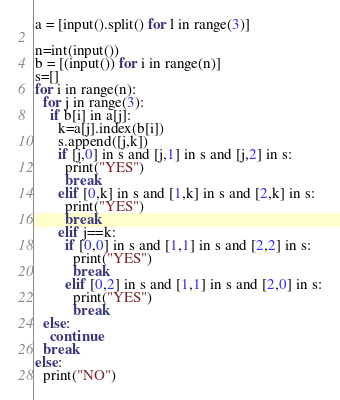<code> <loc_0><loc_0><loc_500><loc_500><_Python_>a = [input().split() for l in range(3)]

n=int(input())
b = [(input()) for i in range(n)]
s=[]
for i in range(n):
  for j in range(3):
    if b[i] in a[j]:
      k=a[j].index(b[i])
      s.append([j,k])
      if [j,0] in s and [j,1] in s and [j,2] in s:
        print("YES")
        break
      elif [0,k] in s and [1,k] in s and [2,k] in s:
        print("YES")
        break
      elif j==k:
        if [0,0] in s and [1,1] in s and [2,2] in s:
          print("YES")
          break
        elif [0,2] in s and [1,1] in s and [2,0] in s:
          print("YES")
          break
  else:
    continue
  break
else:
  print("NO")</code> 